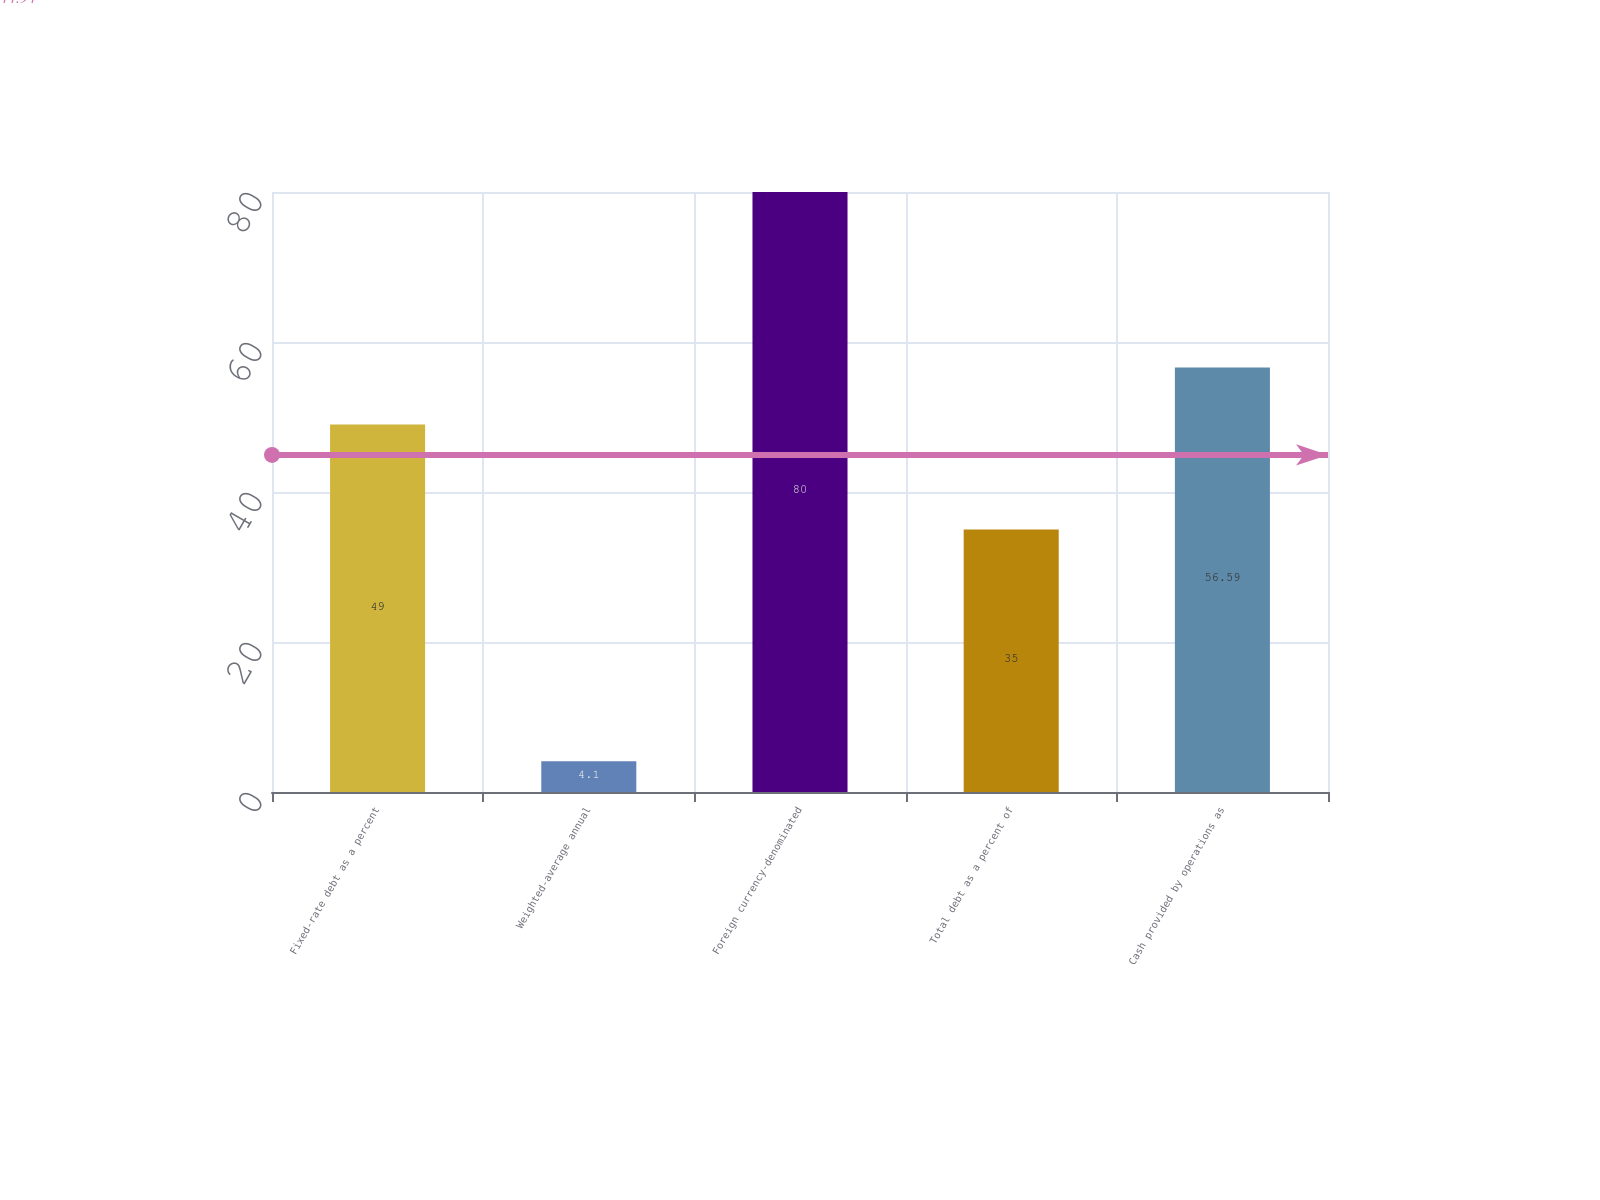Convert chart. <chart><loc_0><loc_0><loc_500><loc_500><bar_chart><fcel>Fixed-rate debt as a percent<fcel>Weighted-average annual<fcel>Foreign currency-denominated<fcel>Total debt as a percent of<fcel>Cash provided by operations as<nl><fcel>49<fcel>4.1<fcel>80<fcel>35<fcel>56.59<nl></chart> 